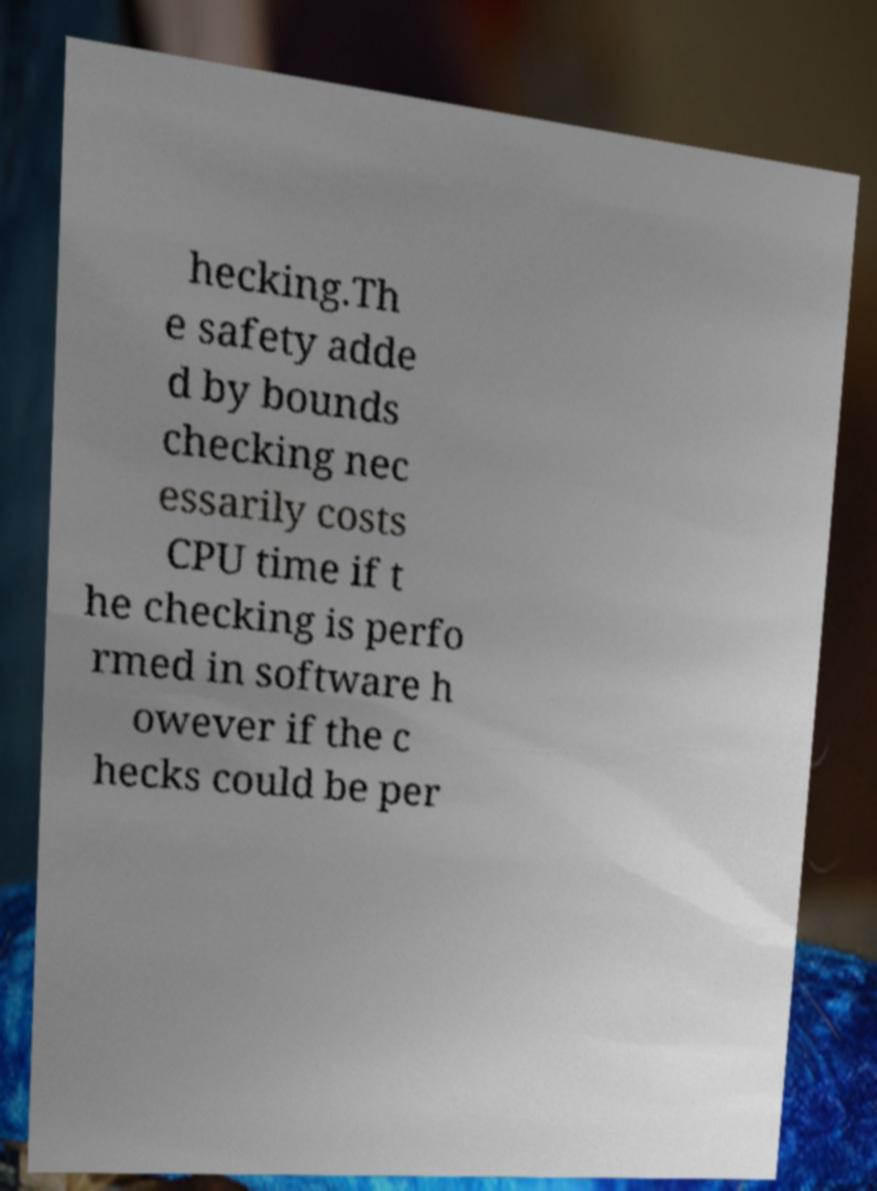What messages or text are displayed in this image? I need them in a readable, typed format. hecking.Th e safety adde d by bounds checking nec essarily costs CPU time if t he checking is perfo rmed in software h owever if the c hecks could be per 